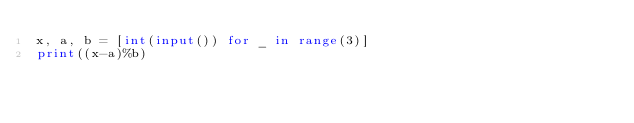Convert code to text. <code><loc_0><loc_0><loc_500><loc_500><_Python_>x, a, b = [int(input()) for _ in range(3)]
print((x-a)%b)
</code> 